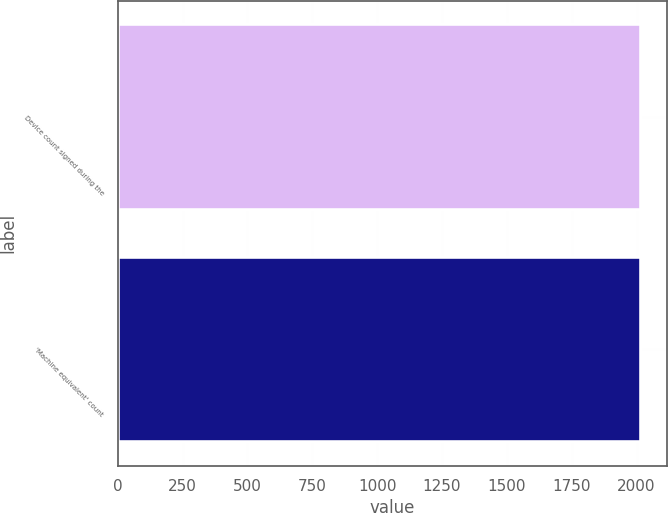Convert chart to OTSL. <chart><loc_0><loc_0><loc_500><loc_500><bar_chart><fcel>Device count signed during the<fcel>'Machine equivalent' count<nl><fcel>2018<fcel>2018.1<nl></chart> 